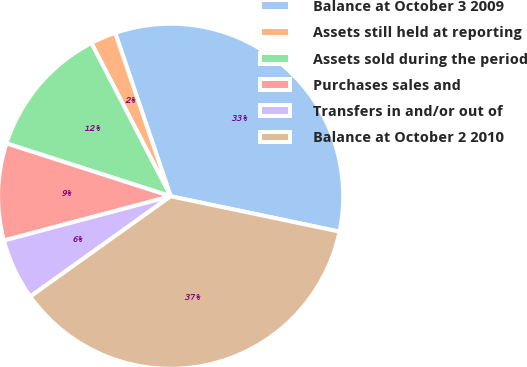<chart> <loc_0><loc_0><loc_500><loc_500><pie_chart><fcel>Balance at October 3 2009<fcel>Assets still held at reporting<fcel>Assets sold during the period<fcel>Purchases sales and<fcel>Transfers in and/or out of<fcel>Balance at October 2 2010<nl><fcel>33.49%<fcel>2.39%<fcel>12.44%<fcel>9.09%<fcel>5.74%<fcel>36.84%<nl></chart> 